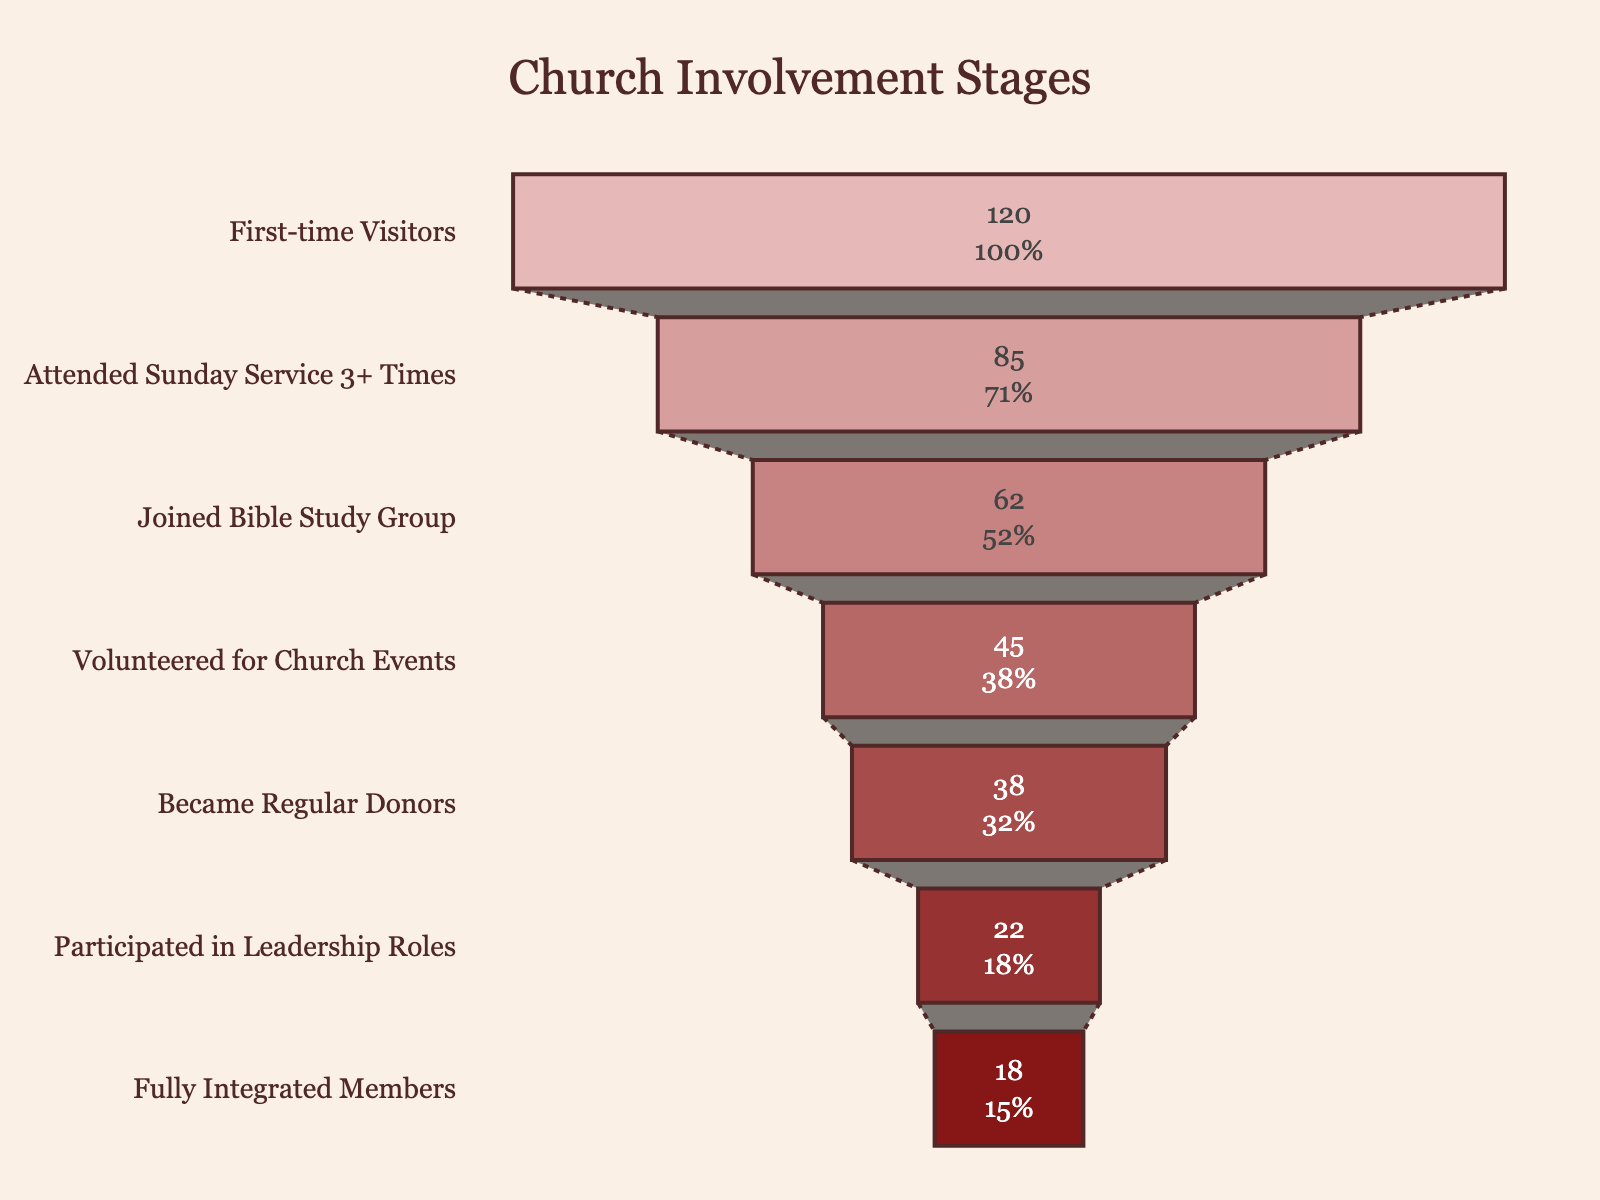What's the title of the funnel chart? The title is located at the top of the funnel chart and typically describes the main focus of the visualization. It helps viewers understand the context of the data.
Answer: Church Involvement Stages How many stages are there in the chart? The stages can be identified by counting the distinct sections or labels on the y-axis of the chart.
Answer: 7 What stage has the highest number of people? The stage with the highest number of people will be the widest section at the top of the funnel.
Answer: First-time Visitors What stage has the lowest number of people? The stage with the lowest number of people will be the narrowest section at the bottom of the funnel.
Answer: Fully Integrated Members How many people became regular donors? Look at the specific stage labeled "Became Regular Donors" to find the corresponding number of people.
Answer: 38 What percentage of first-time visitors attended Sunday service 3 or more times? Calculate the percentage by dividing the number of people who attended Sunday service 3 or more times by the number of first-time visitors, then multiply by 100.
Answer: (85 / 120) * 100 = 70.83% Are there more people attending Sunday service 3 or more times compared to those who joined the Bible study group? Compare the numbers for these two stages to see which is higher.
Answer: Yes, 85 > 62 What is the difference in the number of people between those who volunteered for church events and those who participated in leadership roles? Subtract the number of people who participated in leadership roles from those who volunteered for church events to find the difference.
Answer: 45 - 22 = 23 What fraction of first-time visitors ultimately became fully integrated members? Divide the number of fully integrated members by the number of first-time visitors and simplify the fraction if possible.
Answer: 18 / 120 = 3 / 20 Which stage saw the biggest drop in the number of people compared to the previous stage? Calculate the difference in the number of people between each consecutive stage and identify the largest drop.
Answer: Attended Sunday Service 3+ Times to Joined Bible Study Group (85 - 62 = 23) 